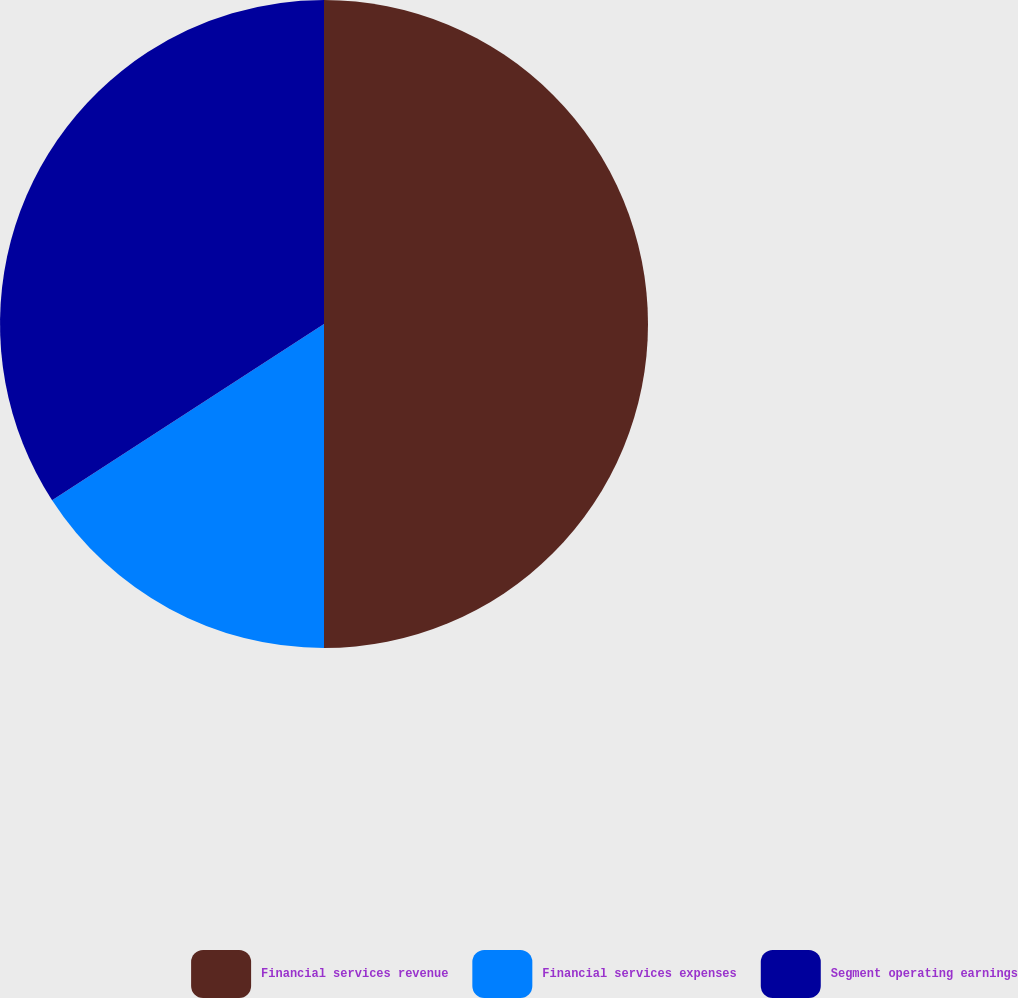Convert chart to OTSL. <chart><loc_0><loc_0><loc_500><loc_500><pie_chart><fcel>Financial services revenue<fcel>Financial services expenses<fcel>Segment operating earnings<nl><fcel>50.0%<fcel>15.85%<fcel>34.15%<nl></chart> 